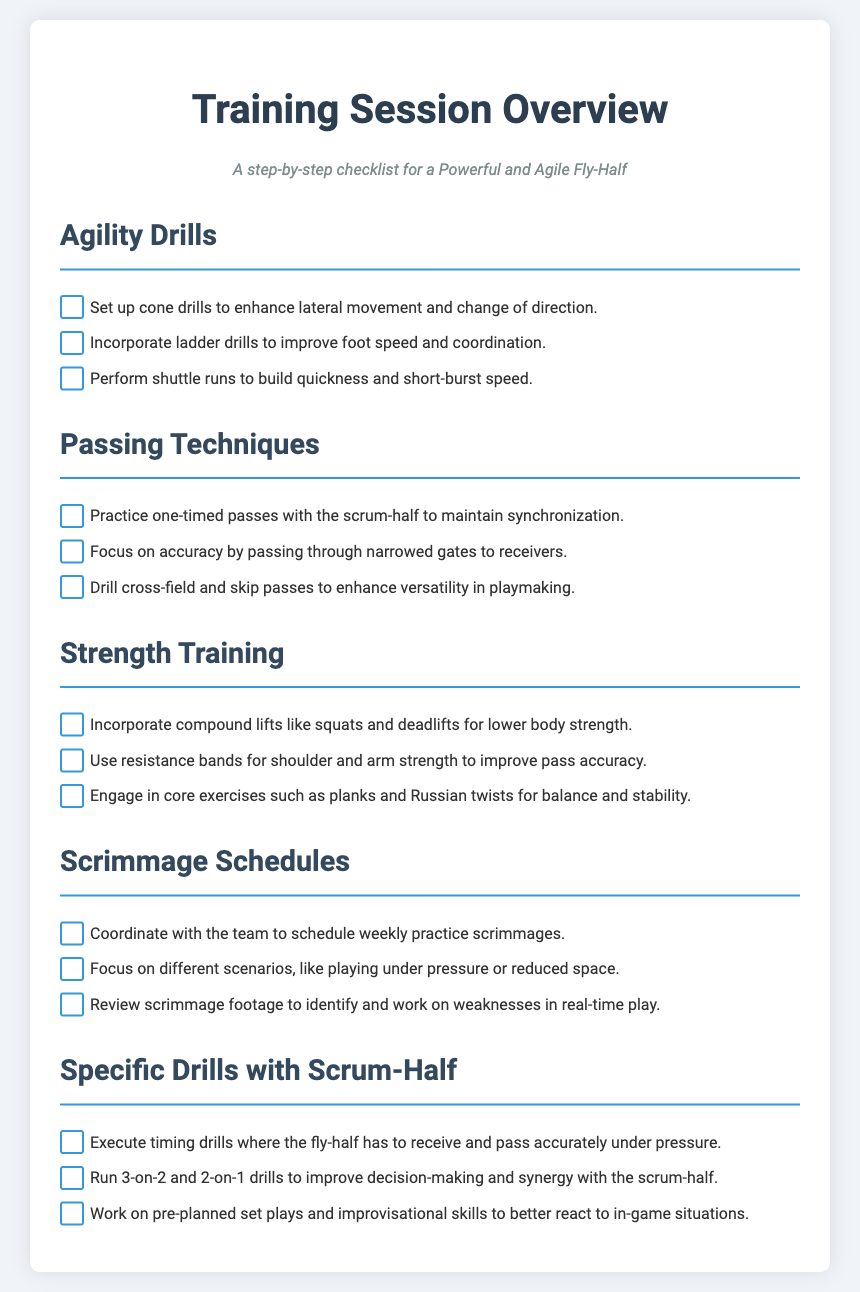What is the title of the document? The title appears at the top of the document as the main heading.
Answer: Training Session Overview What agility drill is performed to build quickness? The document lists specific drills under the Agility Drills section.
Answer: Shuttle runs How many types of passing techniques are mentioned? By counting the items under the Passing Techniques section, you can determine the number.
Answer: Three What compound lifts are recommended for strength training? The document specifies particular strength-training exercises.
Answer: Squats and deadlifts When should scrimmages be scheduled according to the document? The document provides recommendations for scheduling scrimmages.
Answer: Weekly What specific drill focuses on receiving and passing under pressure? The document describes drills tailored for synchronization between the fly-half and scrum-half.
Answer: Timing drills Which technique improves shoulder and arm strength? The Strength Training section mentions specific tools used for strength exercises.
Answer: Resistance bands What type of drills enhance decision-making with the scrum-half? The document outlines drills designed to improve both players' synergy.
Answer: 3-on-2 and 2-on-1 drills 